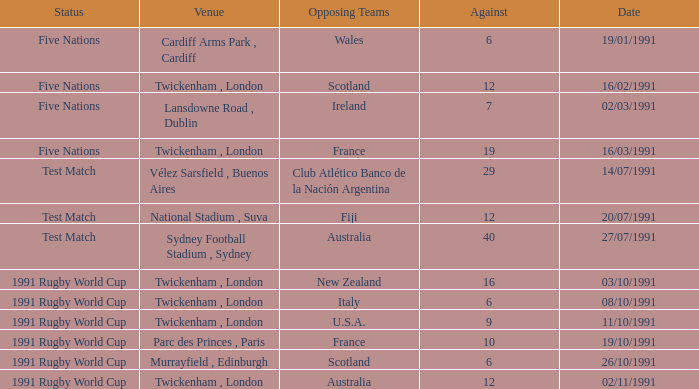What is Date, when Opposing Teams is "Australia", and when Venue is "Twickenham , London"? 02/11/1991. 